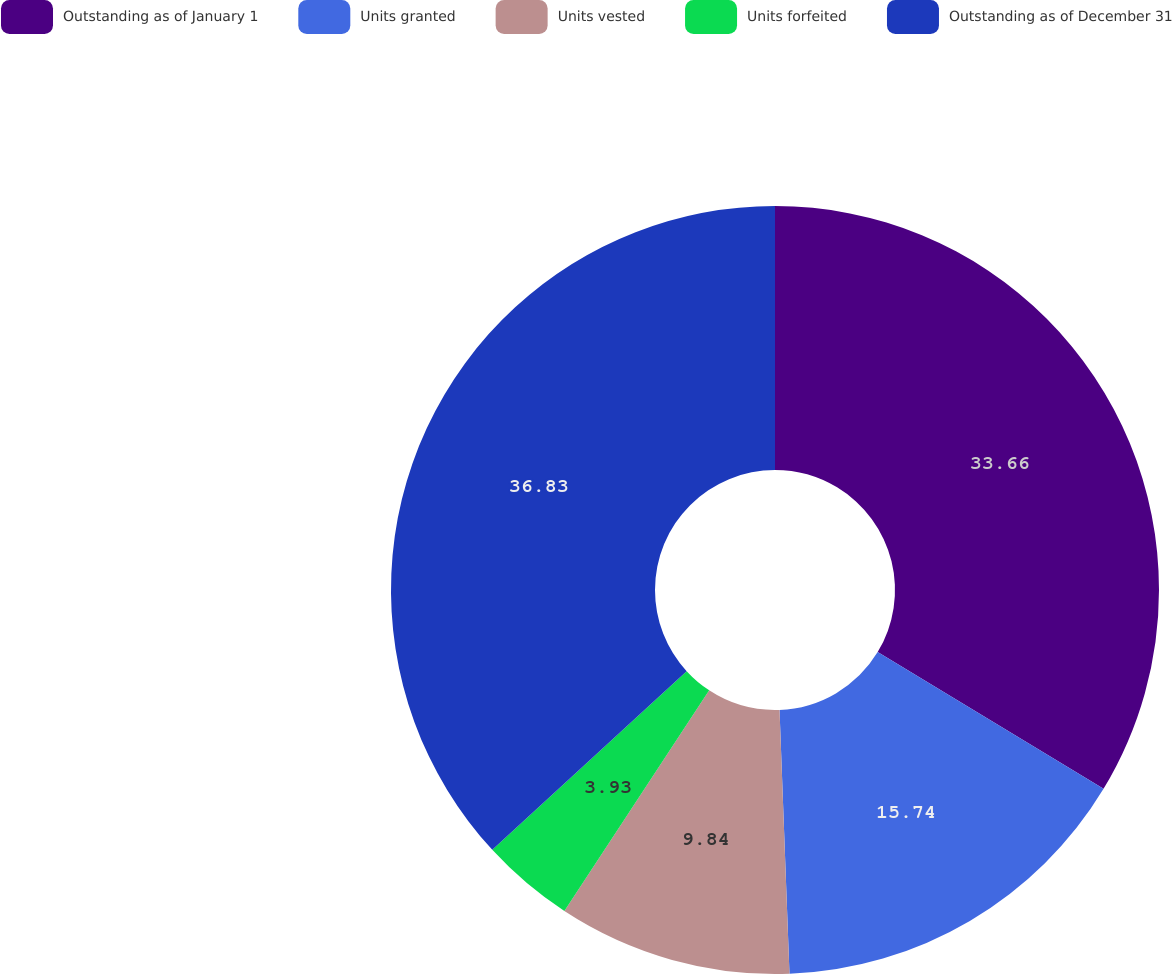<chart> <loc_0><loc_0><loc_500><loc_500><pie_chart><fcel>Outstanding as of January 1<fcel>Units granted<fcel>Units vested<fcel>Units forfeited<fcel>Outstanding as of December 31<nl><fcel>33.66%<fcel>15.74%<fcel>9.84%<fcel>3.93%<fcel>36.83%<nl></chart> 